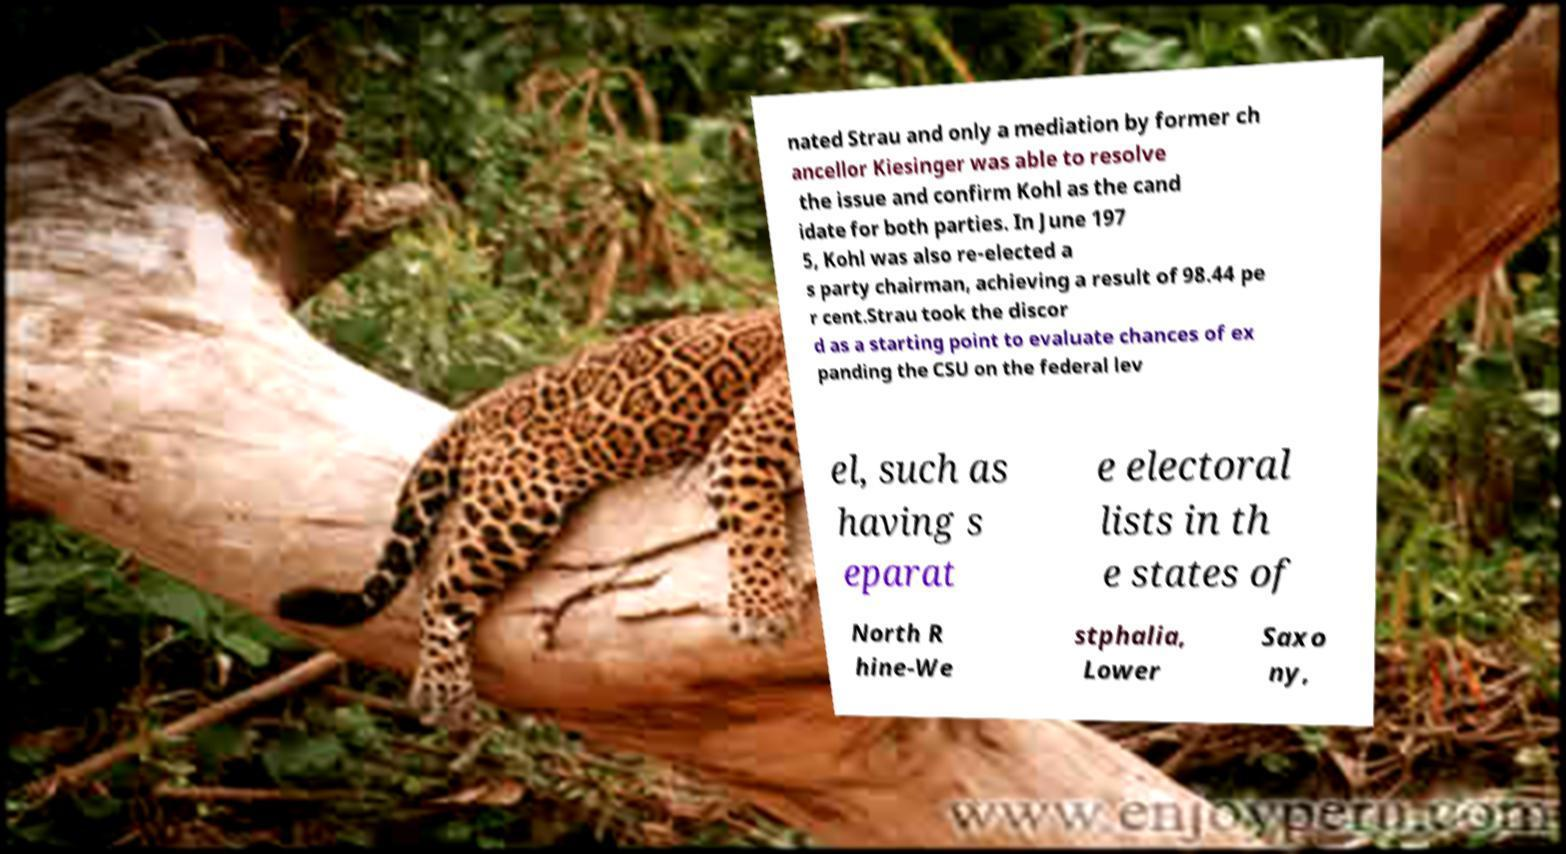I need the written content from this picture converted into text. Can you do that? nated Strau and only a mediation by former ch ancellor Kiesinger was able to resolve the issue and confirm Kohl as the cand idate for both parties. In June 197 5, Kohl was also re-elected a s party chairman, achieving a result of 98.44 pe r cent.Strau took the discor d as a starting point to evaluate chances of ex panding the CSU on the federal lev el, such as having s eparat e electoral lists in th e states of North R hine-We stphalia, Lower Saxo ny, 